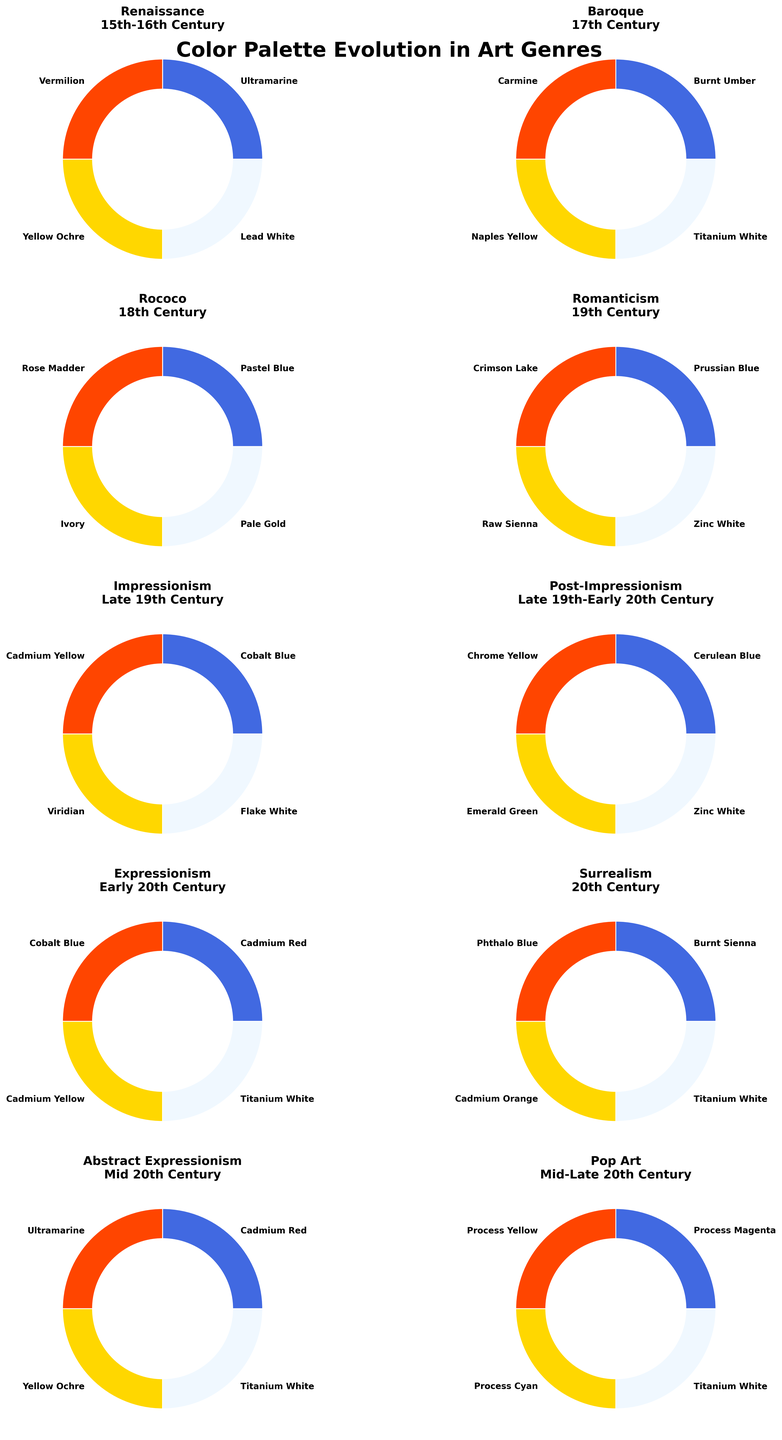What is the title of the figure? The title appears at the top of the figure and reads "Color Palette Evolution in Art Genres".
Answer: Color Palette Evolution in Art Genres How many art genres are represented on the figure? Each subplot represents an art genre, and there are 10 of these subplots.
Answer: 10 Which primary color is consistently used in the Baroque and Abstract Expressionism genres? By looking at the labels in the subplots for both genres, Burnt Umber and Cadmium Red appear. Here, the primary color for both genres is Cadmium Red.
Answer: Cadmium Red Between the Renaissance and Rococo periods, which genre uses 'Rose Madder' as a secondary color? By observing the figure, the Rococo genre, distinguishes 'Rose Madder' as a secondary color in its respective subplot.
Answer: Rococo In which period do you see the use of 'Cerulean Blue' as a primary color? By scanning through the labels in the subplots, it is found in the Post-Impressionism period.
Answer: Post-Impressionism What colors are depicted in the Impressionism genre? The Impressionism genre's subplot shows Cobalt Blue (Primary), Cadmium Yellow (Secondary), Viridian (Tertiary), and Flake White (Quaternary).
Answer: Cobalt Blue, Cadmium Yellow, Viridian, Flake White Which genre has the primary color 'Prussian Blue'? The Romanticism genre's subplot indicates Prussian Blue as its primary color.
Answer: Romanticism What are the tertiary colors for Baroque and Surrealism genres? By inspecting the subplots for both genres, the tertiary colors are Naples Yellow (Baroque) and Cadmium Orange (Surrealism).
Answer: Naples Yellow (Baroque), Cadmium Orange (Surrealism) Which genres use white as a quaternary color? The genres with Titanium White and other variations are: Baroque, Romanticism, Expressionism, Surrealism, and Abstract Expressionism; as per each genre's respective subplot.
Answer: Baroque, Romanticism, Expressionism, Surrealism, Abstract Expressionism How many genres use two shades of blue in their palettes? By examining each subplot, the Impressionism and Expressionism genres each contain Cobalt Blue and one other shade of blue in their color palettes totaling two.
Answer: 2 